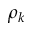Convert formula to latex. <formula><loc_0><loc_0><loc_500><loc_500>\rho _ { k }</formula> 